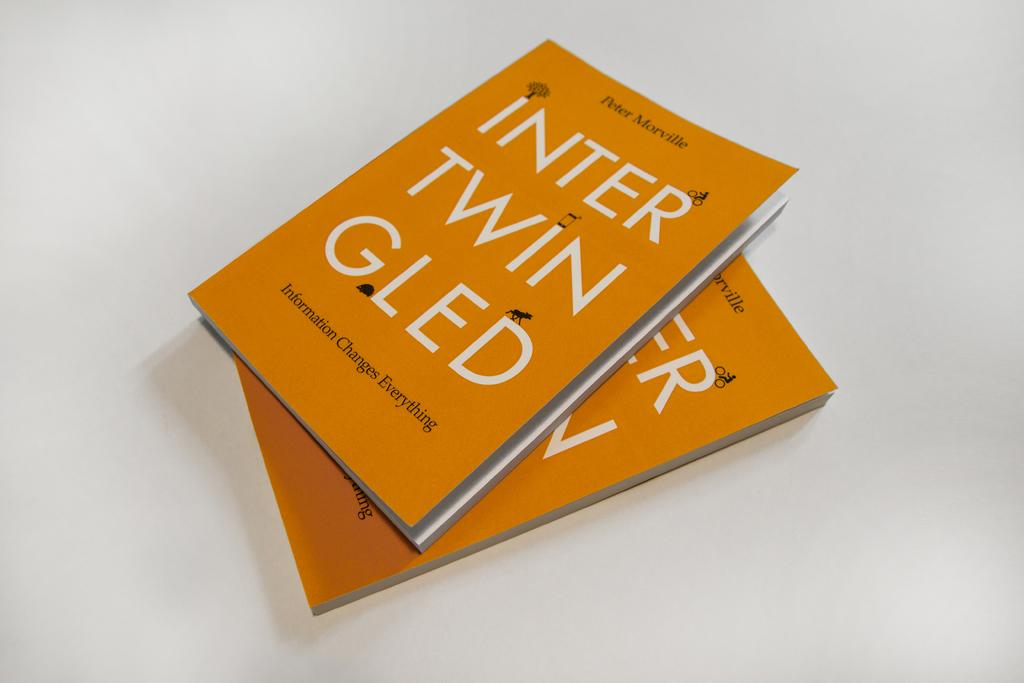Provide a one-sentence caption for the provided image. Two copies of a book written by Peter Morville. 